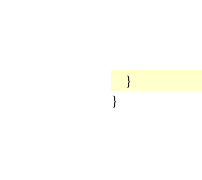<code> <loc_0><loc_0><loc_500><loc_500><_Java_>    }
}
</code> 